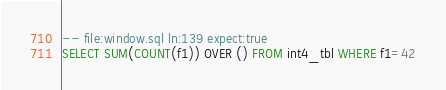<code> <loc_0><loc_0><loc_500><loc_500><_SQL_>-- file:window.sql ln:139 expect:true
SELECT SUM(COUNT(f1)) OVER () FROM int4_tbl WHERE f1=42
</code> 